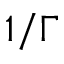Convert formula to latex. <formula><loc_0><loc_0><loc_500><loc_500>1 / \Gamma</formula> 